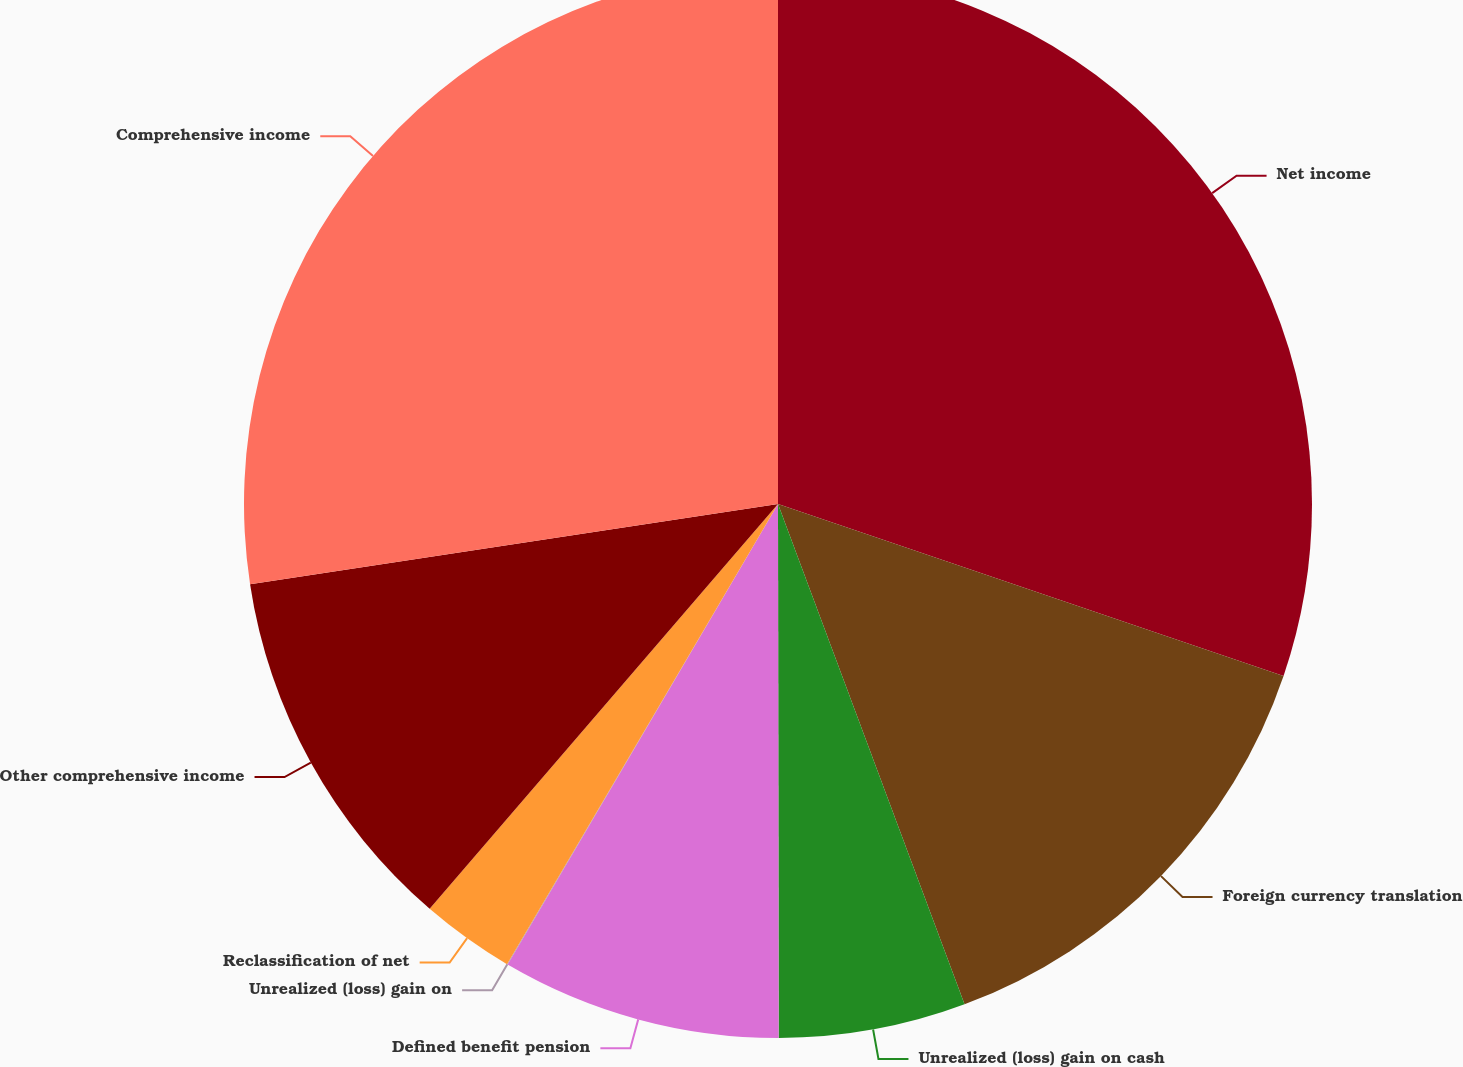<chart> <loc_0><loc_0><loc_500><loc_500><pie_chart><fcel>Net income<fcel>Foreign currency translation<fcel>Unrealized (loss) gain on cash<fcel>Defined benefit pension<fcel>Unrealized (loss) gain on<fcel>Reclassification of net<fcel>Other comprehensive income<fcel>Comprehensive income<nl><fcel>30.22%<fcel>14.1%<fcel>5.66%<fcel>8.47%<fcel>0.02%<fcel>2.84%<fcel>11.29%<fcel>27.4%<nl></chart> 